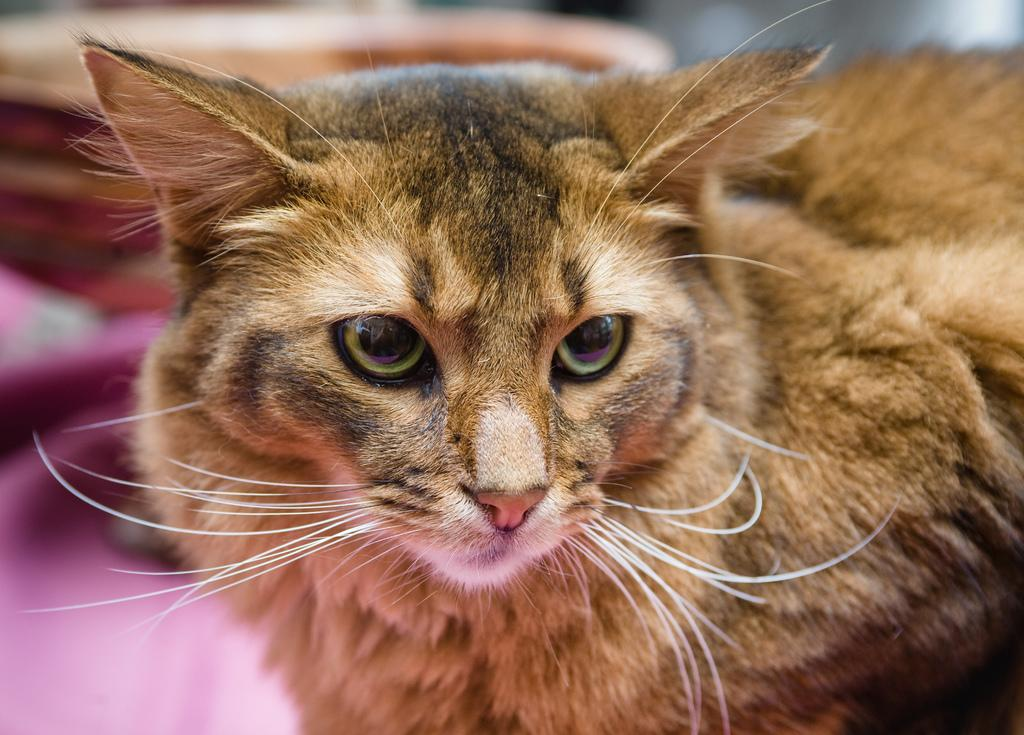What is the main subject in the center of the image? There is a cat in the center of the image. What type of waste can be seen in the cemetery in the image? There is no cemetery or waste present in the image; it features a cat in the center. 